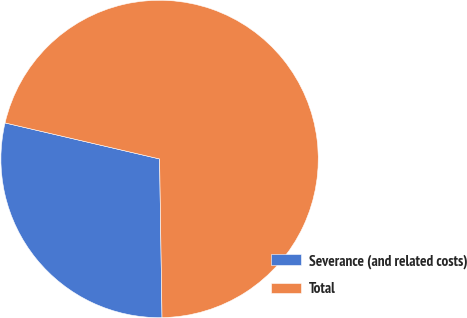Convert chart to OTSL. <chart><loc_0><loc_0><loc_500><loc_500><pie_chart><fcel>Severance (and related costs)<fcel>Total<nl><fcel>28.89%<fcel>71.11%<nl></chart> 